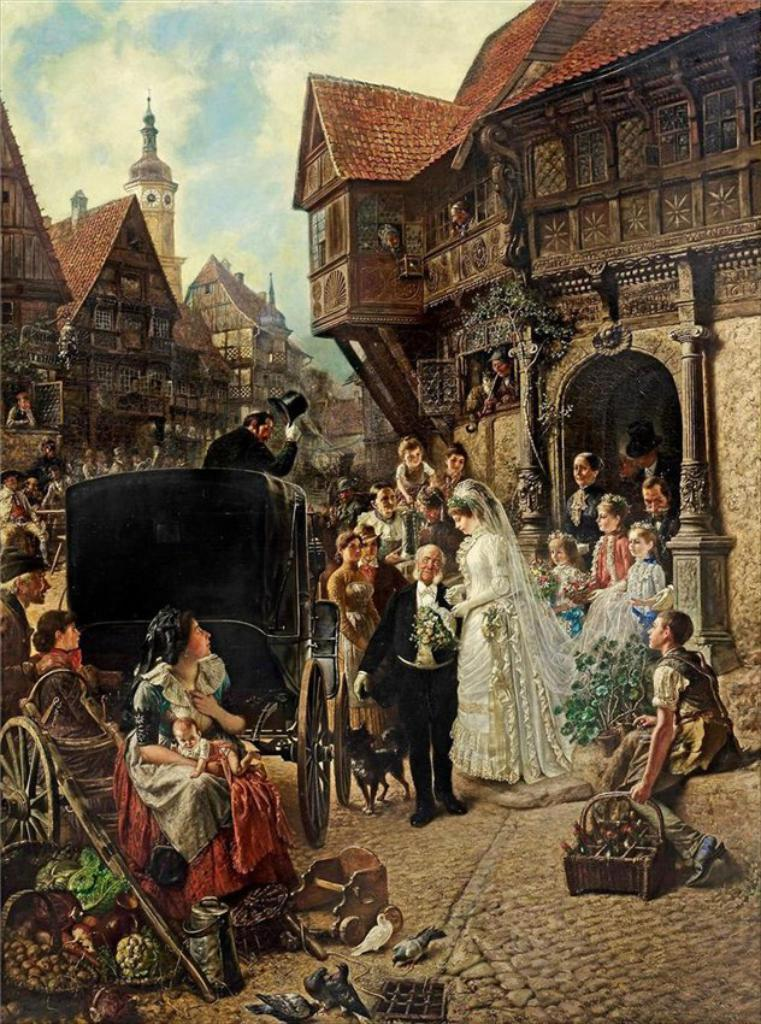What is the main subject of the image? The main subject of the image is a picture. What can be seen in the picture? There are people standing in the picture, as well as a horse cart and homes. What is visible at the top of the picture? The sky is visible at the top of the picture. Where is the cemetery located in the image? There is no cemetery present in the image. What type of table is visible in the picture? There is no table visible in the picture; it features a horse cart instead. 